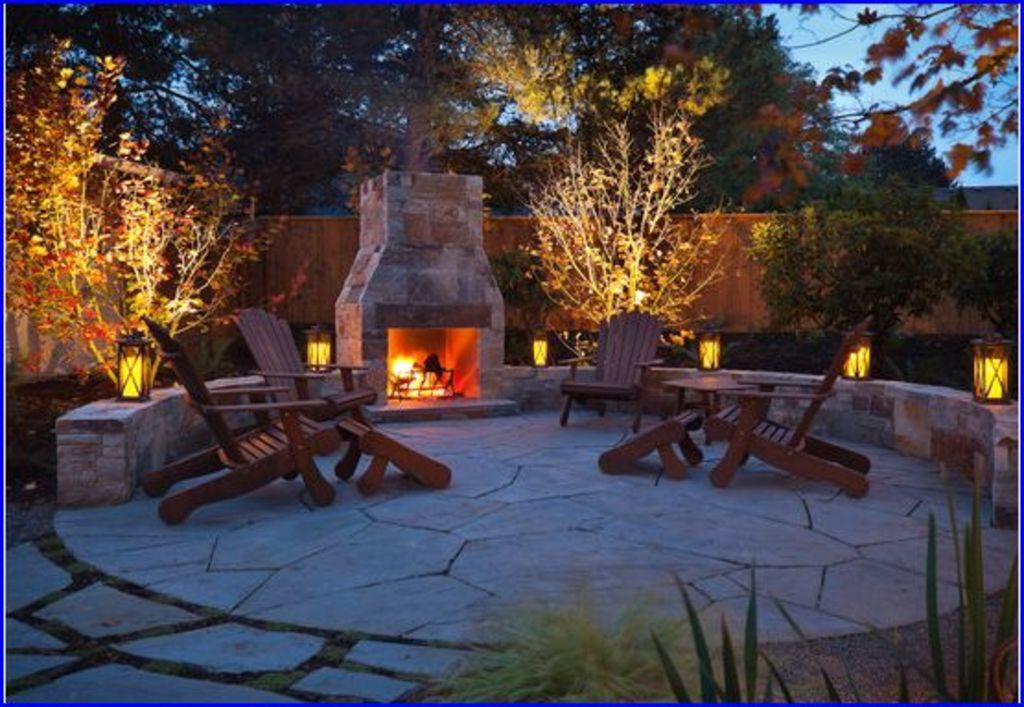How many chairs are on the floor in the image? There are four chairs on the floor in the image. What can be seen in the background of the image? In the background, there is a fence, lamps, trees, a building, and the sky. What might suggest that the image was taken outside a house? The presence of a fence, trees, and a building in the background may suggest that the image was taken outside a house. How many bikes are parked under the shade of the trees in the image? There are no bikes or shades visible in the image; it only shows four chairs on the floor and various elements in the background. 